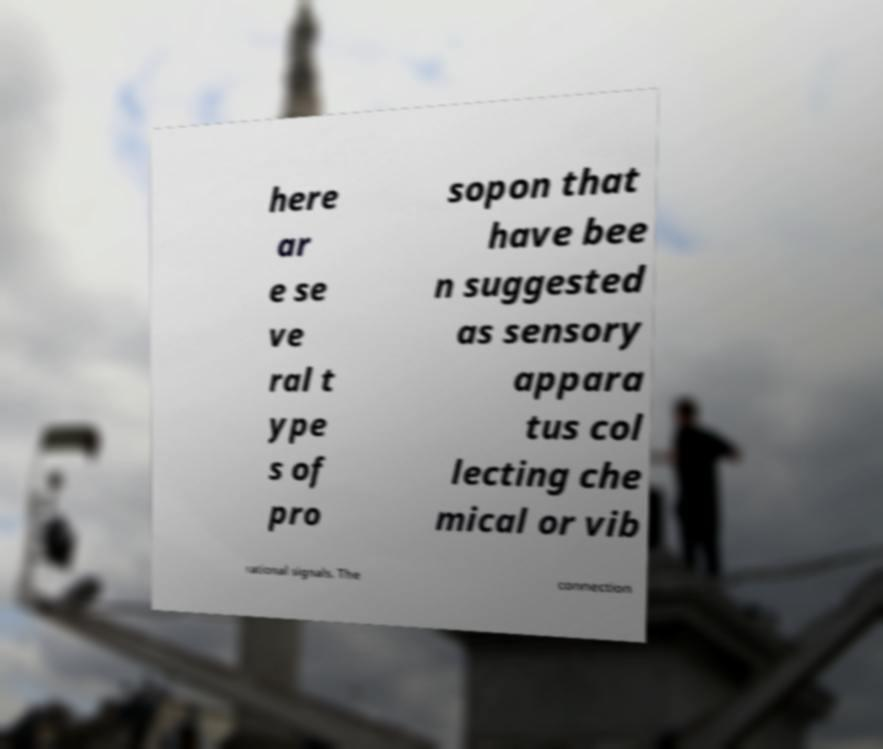Could you assist in decoding the text presented in this image and type it out clearly? here ar e se ve ral t ype s of pro sopon that have bee n suggested as sensory appara tus col lecting che mical or vib rational signals. The connection 